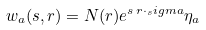<formula> <loc_0><loc_0><loc_500><loc_500>w _ { a } ( s , { r } ) = N ( { r } ) e ^ { s \, { r } \cdot _ { s } i g m a } \eta _ { a }</formula> 